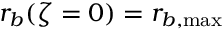Convert formula to latex. <formula><loc_0><loc_0><loc_500><loc_500>r _ { b } ( \zeta = 0 ) = r _ { b , \max }</formula> 